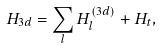<formula> <loc_0><loc_0><loc_500><loc_500>H _ { 3 d } = \sum _ { l } H _ { l } ^ { ( 3 d ) } + H _ { t } ,</formula> 